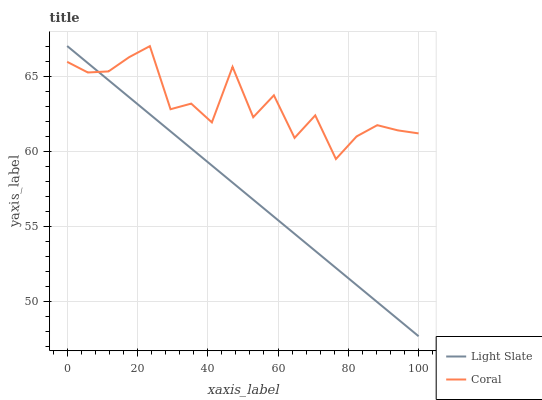Does Light Slate have the minimum area under the curve?
Answer yes or no. Yes. Does Coral have the maximum area under the curve?
Answer yes or no. Yes. Does Coral have the minimum area under the curve?
Answer yes or no. No. Is Light Slate the smoothest?
Answer yes or no. Yes. Is Coral the roughest?
Answer yes or no. Yes. Is Coral the smoothest?
Answer yes or no. No. Does Light Slate have the lowest value?
Answer yes or no. Yes. Does Coral have the lowest value?
Answer yes or no. No. Does Light Slate have the highest value?
Answer yes or no. Yes. Does Coral have the highest value?
Answer yes or no. No. Does Light Slate intersect Coral?
Answer yes or no. Yes. Is Light Slate less than Coral?
Answer yes or no. No. Is Light Slate greater than Coral?
Answer yes or no. No. 